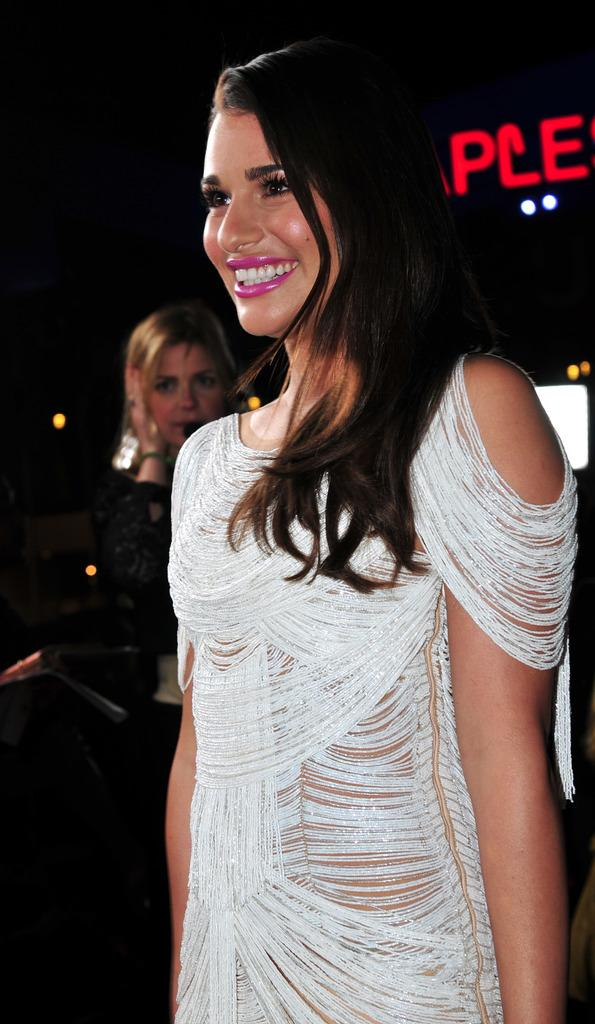Who is the main subject in the image? There is a woman in the image. What is the woman wearing? The woman is wearing a white dress. What is the woman's facial expression? The woman is smiling. Can you describe the other person in the image? There is another woman behind her. What can be seen in the background of the image? There is a name visible in the background of the image. What type of produce can be seen growing in the image? There is no produce visible in the image. What substance is being used to create the name in the background? The image does not provide information about the substance used to create the name in the background. 